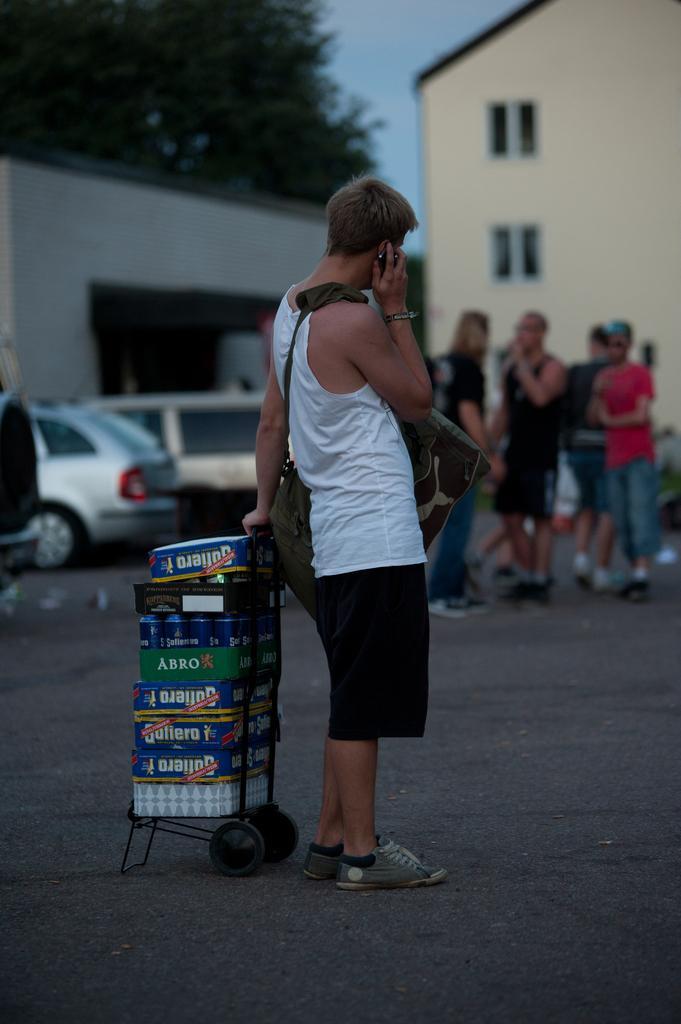Please provide a concise description of this image. In this image I can see the person standing on the road and wearing the white and black color dress and holding the trolley. In the trolley I can see many objects. In the back I can see few more people with different color dresses. To the side there are vehicles. In the background I can see the building, trees and the sky. 